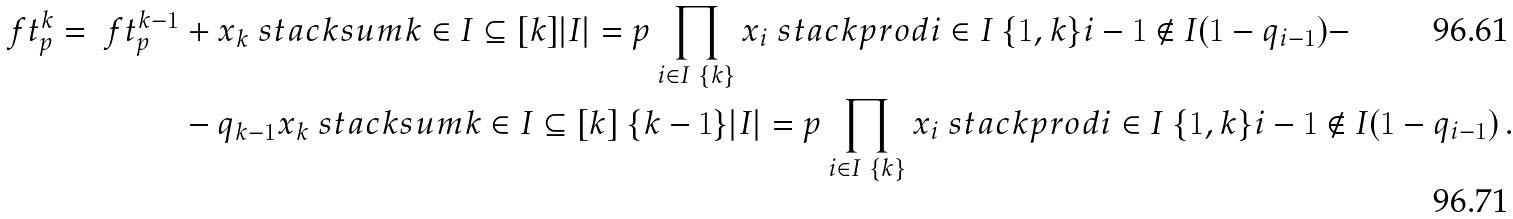<formula> <loc_0><loc_0><loc_500><loc_500>\ f t _ { p } ^ { k } = \ f t _ { p } ^ { k - 1 } & + x _ { k } \ s t a c k s u m { k \in I \subseteq [ k ] } { | I | = p } \prod _ { i \in I \ \{ k \} } x _ { i } \ s t a c k p r o d { i \in I \ \{ 1 , k \} } { i - 1 \not \in I } ( 1 - q _ { i - 1 } ) - \\ & - q _ { k - 1 } x _ { k } \ s t a c k s u m { k \in I \subseteq [ k ] \ \{ k - 1 \} } { | I | = p } \prod _ { i \in I \ \{ k \} } x _ { i } \ s t a c k p r o d { i \in I \ \{ 1 , k \} } { i - 1 \not \in I } ( 1 - q _ { i - 1 } ) \, .</formula> 